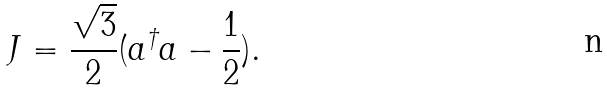<formula> <loc_0><loc_0><loc_500><loc_500>J = \frac { \sqrt { 3 } } { 2 } ( a ^ { \dagger } a - \frac { 1 } { 2 } ) .</formula> 